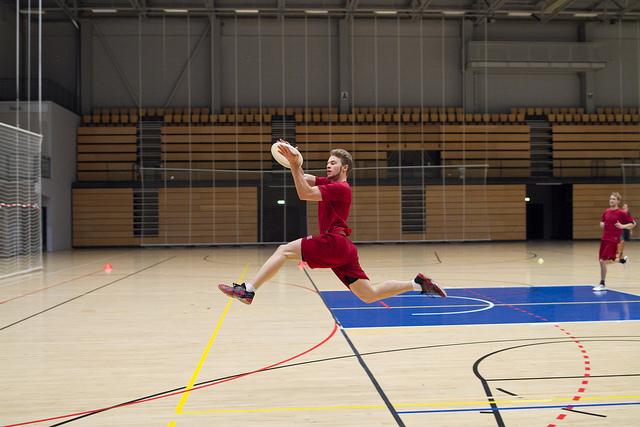What sport is this?
Answer briefly. Frisbee. What is the score?
Give a very brief answer. Unknown. What sport is this man playing?
Short answer required. Frisbee. What is the man kicking?
Concise answer only. Nothing. What sport are they playing?
Answer briefly. Frisbee. Is this person airborne?
Quick response, please. Yes. Is the photo blurry?
Be succinct. No. What is the man catching?
Concise answer only. Frisbee. What game are they playing?
Write a very short answer. Frisbee. 